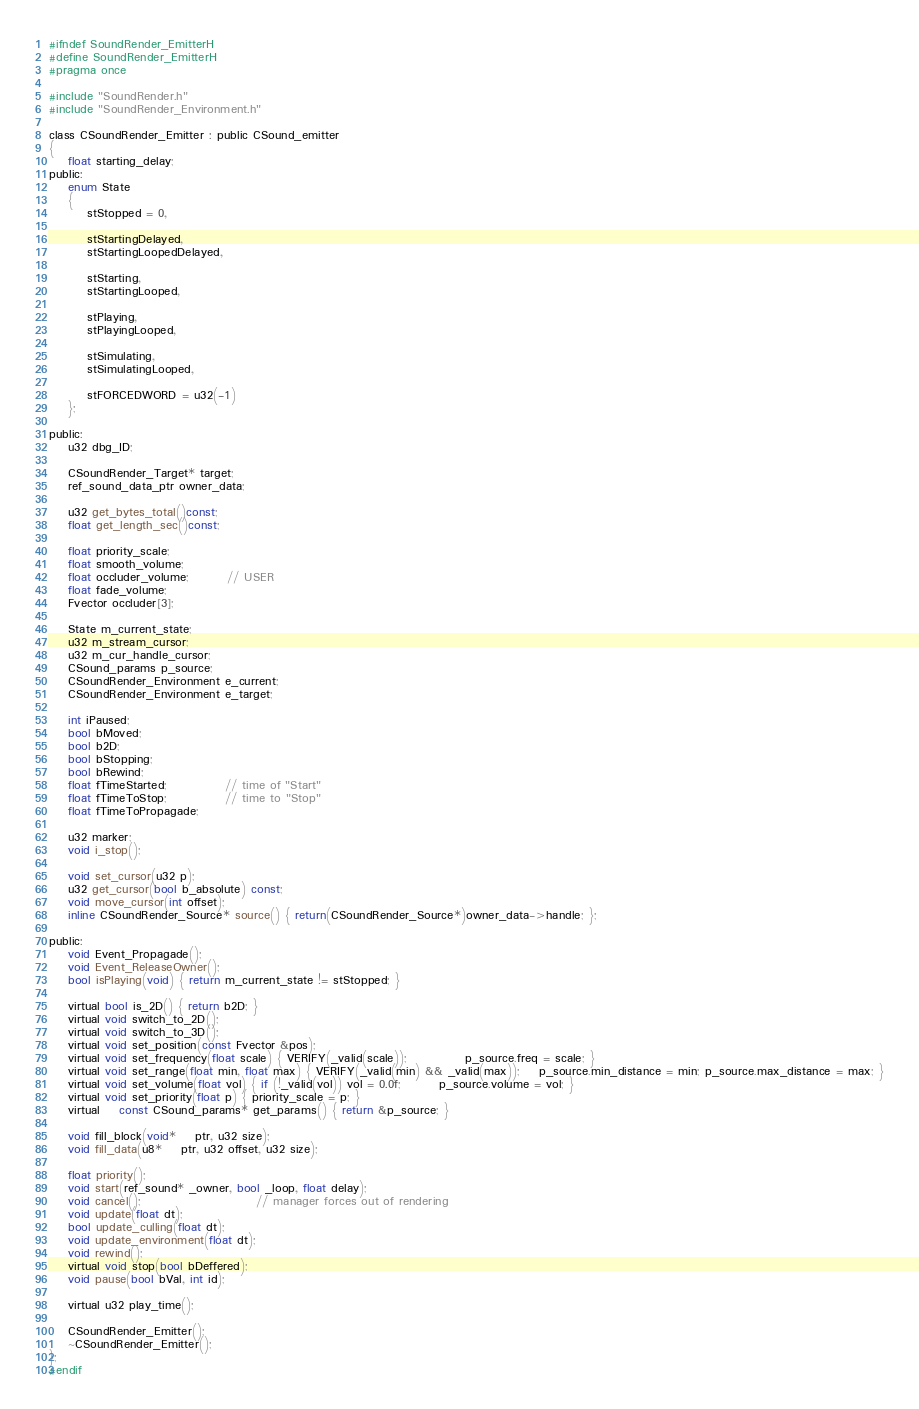Convert code to text. <code><loc_0><loc_0><loc_500><loc_500><_C_>#ifndef SoundRender_EmitterH
#define SoundRender_EmitterH
#pragma once

#include "SoundRender.h"
#include "SoundRender_Environment.h"

class CSoundRender_Emitter : public CSound_emitter
{
	float starting_delay;
public:
	enum State
	{
		stStopped = 0,

		stStartingDelayed,
		stStartingLoopedDelayed,

		stStarting,
		stStartingLooped,

		stPlaying,
		stPlayingLooped,

		stSimulating,
		stSimulatingLooped,

		stFORCEDWORD = u32(-1)
	};

public:
	u32 dbg_ID;

	CSoundRender_Target* target;
	ref_sound_data_ptr owner_data;

	u32 get_bytes_total()const;
	float get_length_sec()const;

	float priority_scale;
	float smooth_volume;
	float occluder_volume;		// USER
	float fade_volume;
	Fvector occluder[3];

	State m_current_state;
	u32 m_stream_cursor;
	u32 m_cur_handle_cursor;
	CSound_params p_source;
	CSoundRender_Environment e_current;
	CSoundRender_Environment e_target;

	int iPaused;
	bool bMoved;
	bool b2D;
	bool bStopping;
	bool bRewind;
	float fTimeStarted;			// time of "Start"
	float fTimeToStop;			// time to "Stop"
	float fTimeToPropagade;

	u32 marker;
	void i_stop();

	void set_cursor(u32 p);
	u32 get_cursor(bool b_absolute) const;
	void move_cursor(int offset);
	inline CSoundRender_Source* source() { return(CSoundRender_Source*)owner_data->handle; };

public:
	void Event_Propagade();
	void Event_ReleaseOwner();
	bool isPlaying(void) { return m_current_state != stStopped; }

	virtual bool is_2D() { return b2D; }
	virtual void switch_to_2D();
	virtual void switch_to_3D();
	virtual void set_position(const Fvector &pos);
	virtual void set_frequency(float scale) { VERIFY(_valid(scale));			p_source.freq = scale; }
	virtual void set_range(float min, float max) { VERIFY(_valid(min) && _valid(max));	p_source.min_distance = min; p_source.max_distance = max; }
	virtual void set_volume(float vol) { if (!_valid(vol)) vol = 0.0f;		p_source.volume = vol; }
	virtual void set_priority(float p) { priority_scale = p; }
	virtual	const CSound_params* get_params() { return &p_source; }

	void fill_block(void*	ptr, u32 size);
	void fill_data(u8*	ptr, u32 offset, u32 size);

	float priority();
	void start(ref_sound* _owner, bool _loop, float delay);
	void cancel();						// manager forces out of rendering
	void update(float dt);
	bool update_culling(float dt);
	void update_environment(float dt);
	void rewind();
	virtual void stop(bool bDeffered);
	void pause(bool bVal, int id);

	virtual u32 play_time();

	CSoundRender_Emitter();
	~CSoundRender_Emitter();
};
#endif</code> 